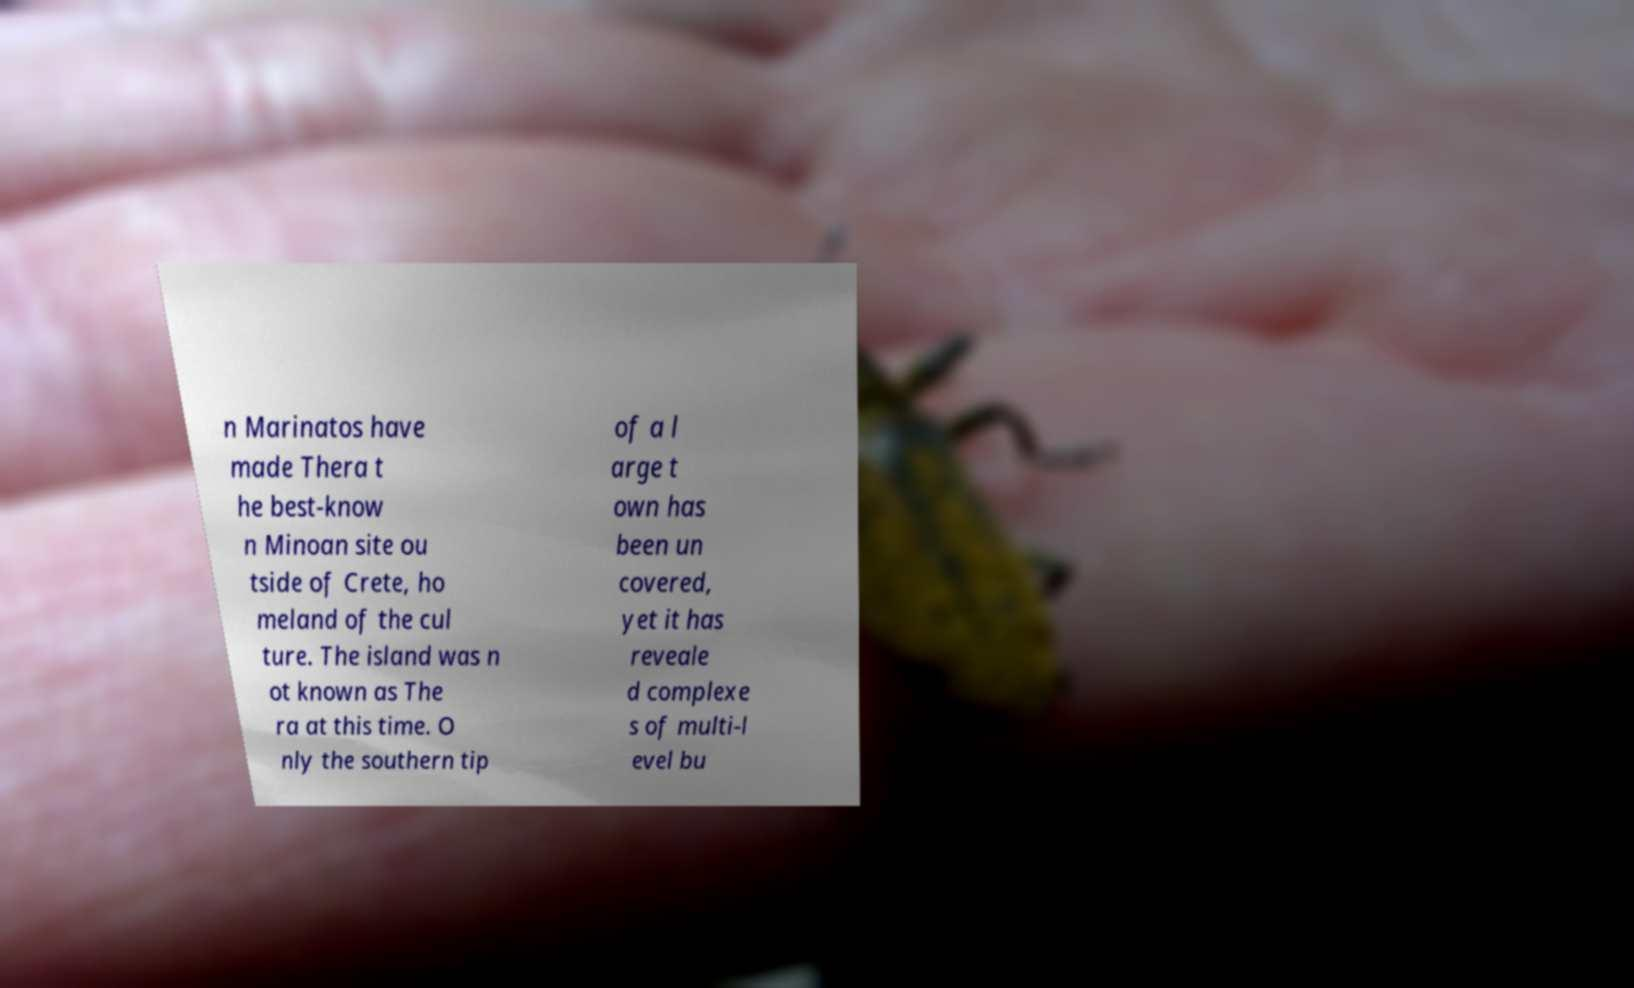Can you read and provide the text displayed in the image?This photo seems to have some interesting text. Can you extract and type it out for me? n Marinatos have made Thera t he best-know n Minoan site ou tside of Crete, ho meland of the cul ture. The island was n ot known as The ra at this time. O nly the southern tip of a l arge t own has been un covered, yet it has reveale d complexe s of multi-l evel bu 